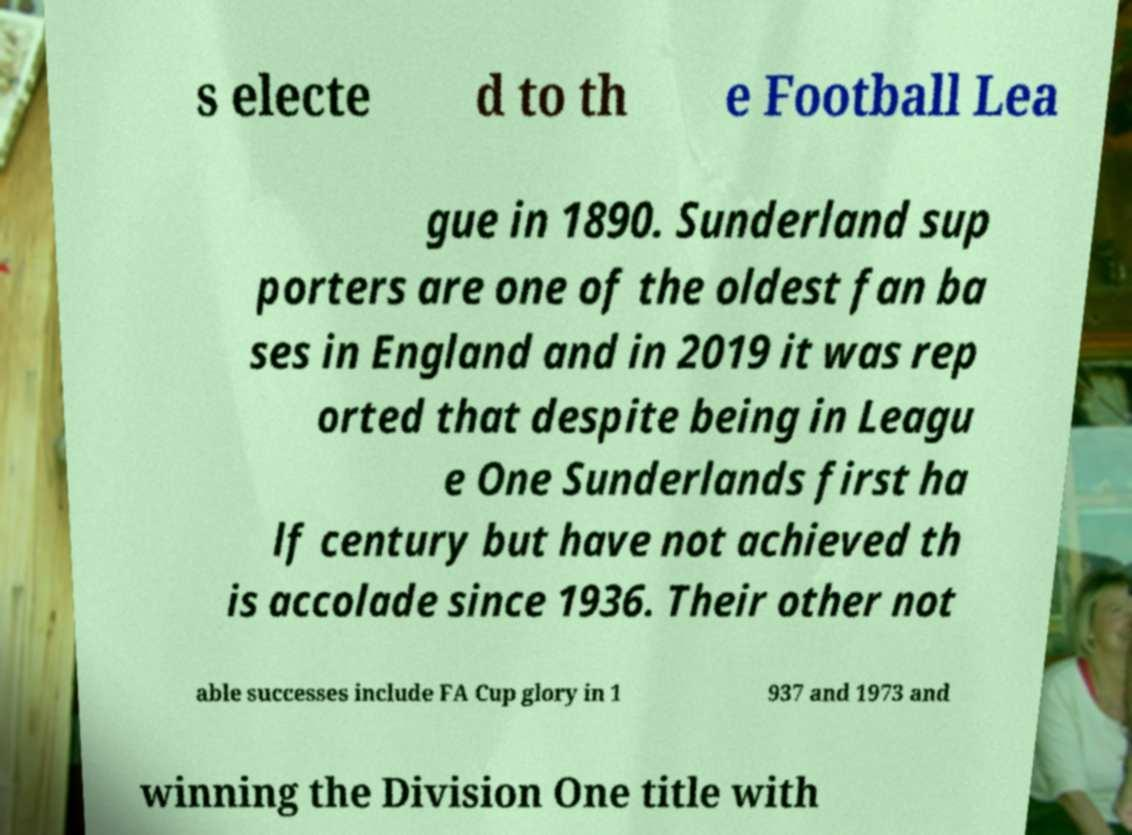What messages or text are displayed in this image? I need them in a readable, typed format. s electe d to th e Football Lea gue in 1890. Sunderland sup porters are one of the oldest fan ba ses in England and in 2019 it was rep orted that despite being in Leagu e One Sunderlands first ha lf century but have not achieved th is accolade since 1936. Their other not able successes include FA Cup glory in 1 937 and 1973 and winning the Division One title with 